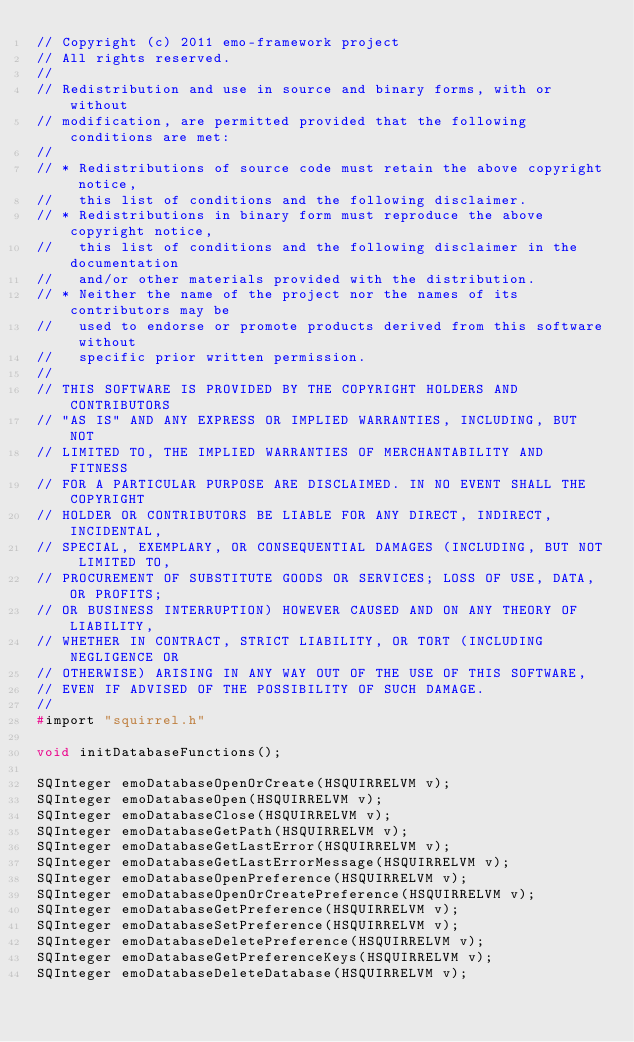Convert code to text. <code><loc_0><loc_0><loc_500><loc_500><_C_>// Copyright (c) 2011 emo-framework project
// All rights reserved.
// 
// Redistribution and use in source and binary forms, with or without
// modification, are permitted provided that the following conditions are met:
// 
// * Redistributions of source code must retain the above copyright notice,
//   this list of conditions and the following disclaimer.
// * Redistributions in binary form must reproduce the above copyright notice,
//   this list of conditions and the following disclaimer in the documentation
//   and/or other materials provided with the distribution.
// * Neither the name of the project nor the names of its contributors may be
//   used to endorse or promote products derived from this software without
//   specific prior written permission.
// 
// THIS SOFTWARE IS PROVIDED BY THE COPYRIGHT HOLDERS AND CONTRIBUTORS 
// "AS IS" AND ANY EXPRESS OR IMPLIED WARRANTIES, INCLUDING, BUT NOT 
// LIMITED TO, THE IMPLIED WARRANTIES OF MERCHANTABILITY AND FITNESS 
// FOR A PARTICULAR PURPOSE ARE DISCLAIMED. IN NO EVENT SHALL THE COPYRIGHT
// HOLDER OR CONTRIBUTORS BE LIABLE FOR ANY DIRECT, INDIRECT, INCIDENTAL,
// SPECIAL, EXEMPLARY, OR CONSEQUENTIAL DAMAGES (INCLUDING, BUT NOT LIMITED TO,
// PROCUREMENT OF SUBSTITUTE GOODS OR SERVICES; LOSS OF USE, DATA, OR PROFITS;
// OR BUSINESS INTERRUPTION) HOWEVER CAUSED AND ON ANY THEORY OF LIABILITY,
// WHETHER IN CONTRACT, STRICT LIABILITY, OR TORT (INCLUDING NEGLIGENCE OR
// OTHERWISE) ARISING IN ANY WAY OUT OF THE USE OF THIS SOFTWARE, 
// EVEN IF ADVISED OF THE POSSIBILITY OF SUCH DAMAGE.
// 
#import "squirrel.h"

void initDatabaseFunctions();

SQInteger emoDatabaseOpenOrCreate(HSQUIRRELVM v);
SQInteger emoDatabaseOpen(HSQUIRRELVM v);
SQInteger emoDatabaseClose(HSQUIRRELVM v);
SQInteger emoDatabaseGetPath(HSQUIRRELVM v);
SQInteger emoDatabaseGetLastError(HSQUIRRELVM v);
SQInteger emoDatabaseGetLastErrorMessage(HSQUIRRELVM v);
SQInteger emoDatabaseOpenPreference(HSQUIRRELVM v);
SQInteger emoDatabaseOpenOrCreatePreference(HSQUIRRELVM v);
SQInteger emoDatabaseGetPreference(HSQUIRRELVM v);
SQInteger emoDatabaseSetPreference(HSQUIRRELVM v);
SQInteger emoDatabaseDeletePreference(HSQUIRRELVM v);
SQInteger emoDatabaseGetPreferenceKeys(HSQUIRRELVM v);
SQInteger emoDatabaseDeleteDatabase(HSQUIRRELVM v);
</code> 